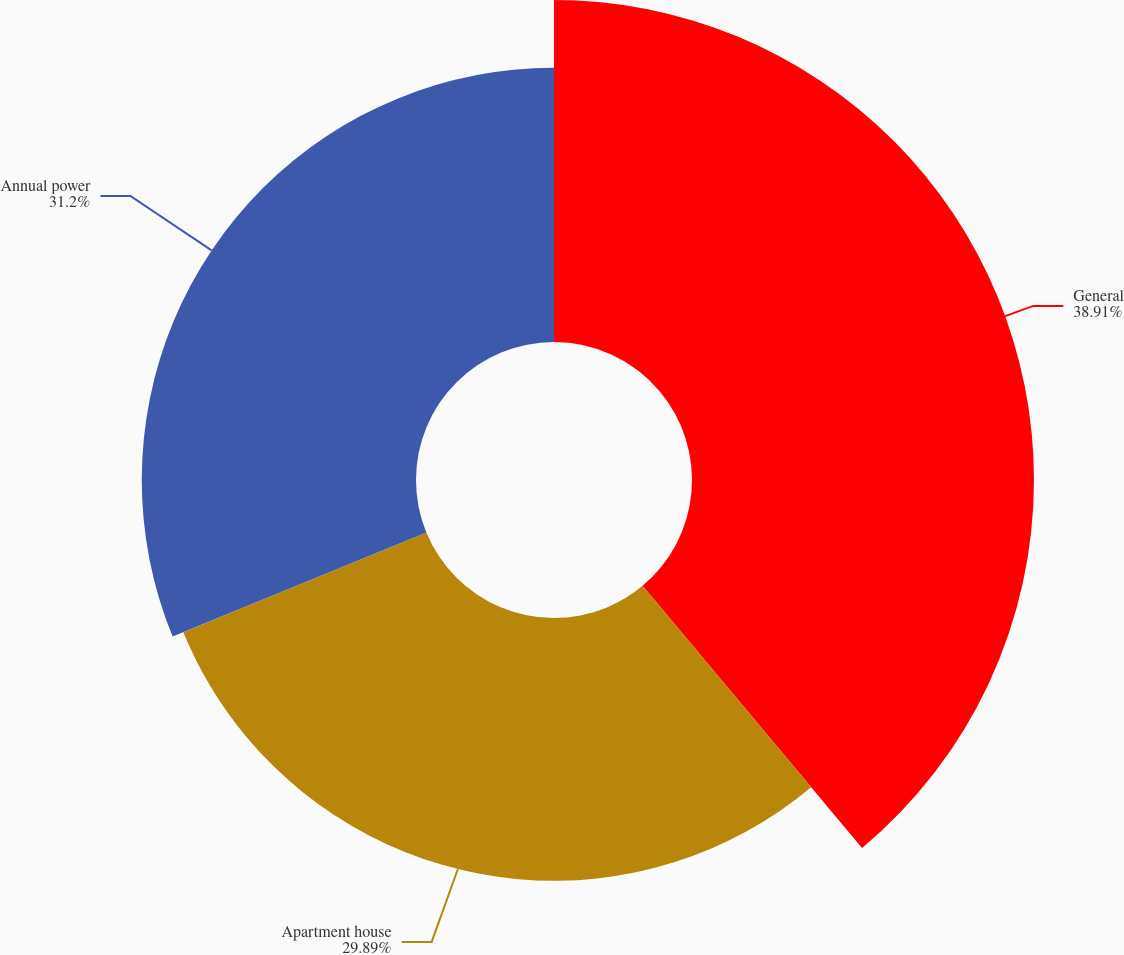<chart> <loc_0><loc_0><loc_500><loc_500><pie_chart><fcel>General<fcel>Apartment house<fcel>Annual power<nl><fcel>38.91%<fcel>29.89%<fcel>31.2%<nl></chart> 